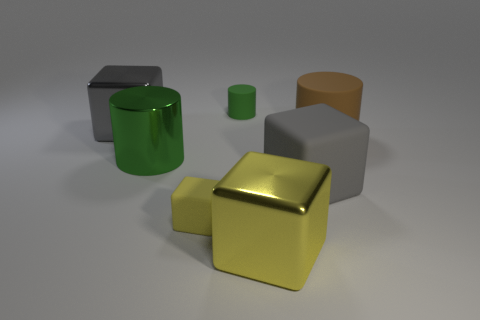Add 1 small green metallic cylinders. How many objects exist? 8 Subtract all cubes. How many objects are left? 3 Add 2 big metallic cylinders. How many big metallic cylinders are left? 3 Add 2 large brown matte objects. How many large brown matte objects exist? 3 Subtract 0 cyan blocks. How many objects are left? 7 Subtract all gray metallic blocks. Subtract all large green cylinders. How many objects are left? 5 